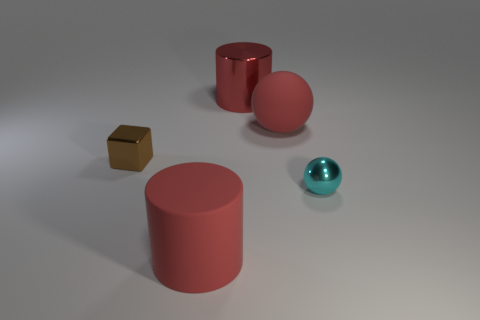Add 5 big blue objects. How many objects exist? 10 Subtract all cubes. How many objects are left? 4 Subtract 0 purple blocks. How many objects are left? 5 Subtract all cyan blocks. Subtract all spheres. How many objects are left? 3 Add 5 cubes. How many cubes are left? 6 Add 4 cyan things. How many cyan things exist? 5 